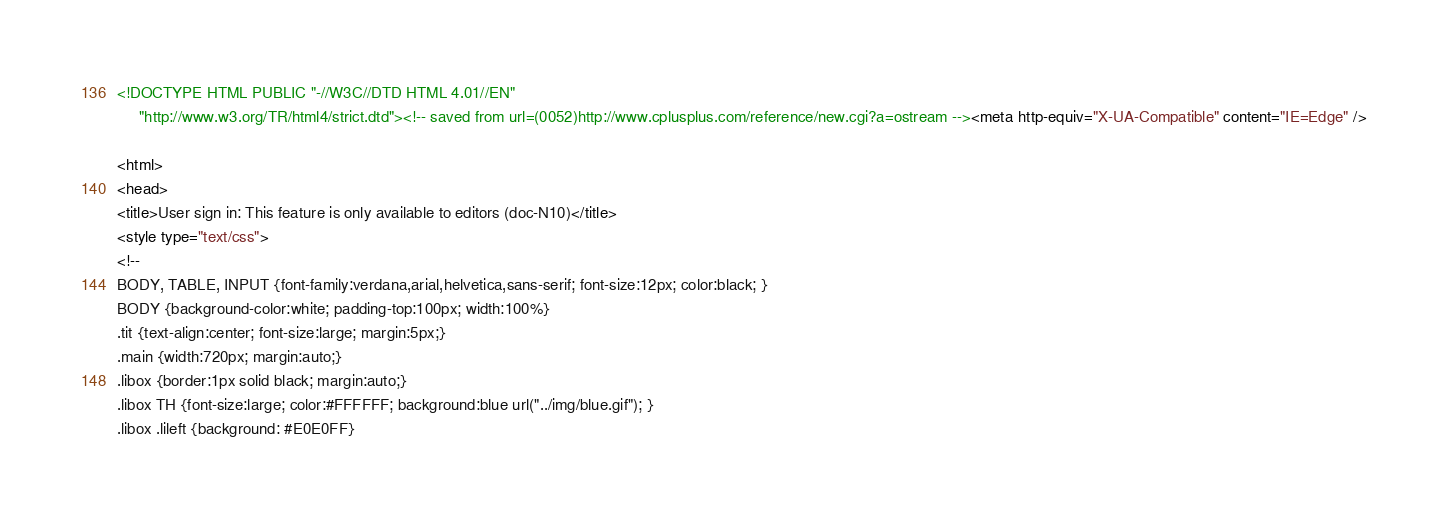<code> <loc_0><loc_0><loc_500><loc_500><_HTML_><!DOCTYPE HTML PUBLIC "-//W3C//DTD HTML 4.01//EN"
     "http://www.w3.org/TR/html4/strict.dtd"><!-- saved from url=(0052)http://www.cplusplus.com/reference/new.cgi?a=ostream --><meta http-equiv="X-UA-Compatible" content="IE=Edge" />

<html>
<head>
<title>User sign in: This feature is only available to editors (doc-N10)</title>
<style type="text/css">
<!--
BODY, TABLE, INPUT {font-family:verdana,arial,helvetica,sans-serif; font-size:12px; color:black; }
BODY {background-color:white; padding-top:100px; width:100%}
.tit {text-align:center; font-size:large; margin:5px;}
.main {width:720px; margin:auto;}
.libox {border:1px solid black; margin:auto;}
.libox TH {font-size:large; color:#FFFFFF; background:blue url("../img/blue.gif"); }
.libox .lileft {background: #E0E0FF}</code> 